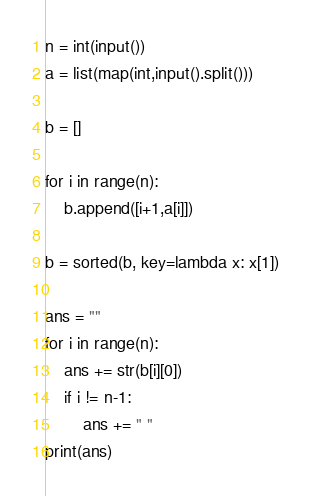<code> <loc_0><loc_0><loc_500><loc_500><_Python_>n = int(input())
a = list(map(int,input().split()))

b = []

for i in range(n):
    b.append([i+1,a[i]])

b = sorted(b, key=lambda x: x[1])

ans = ""
for i in range(n):
    ans += str(b[i][0])
    if i != n-1:
        ans += " "
print(ans)</code> 